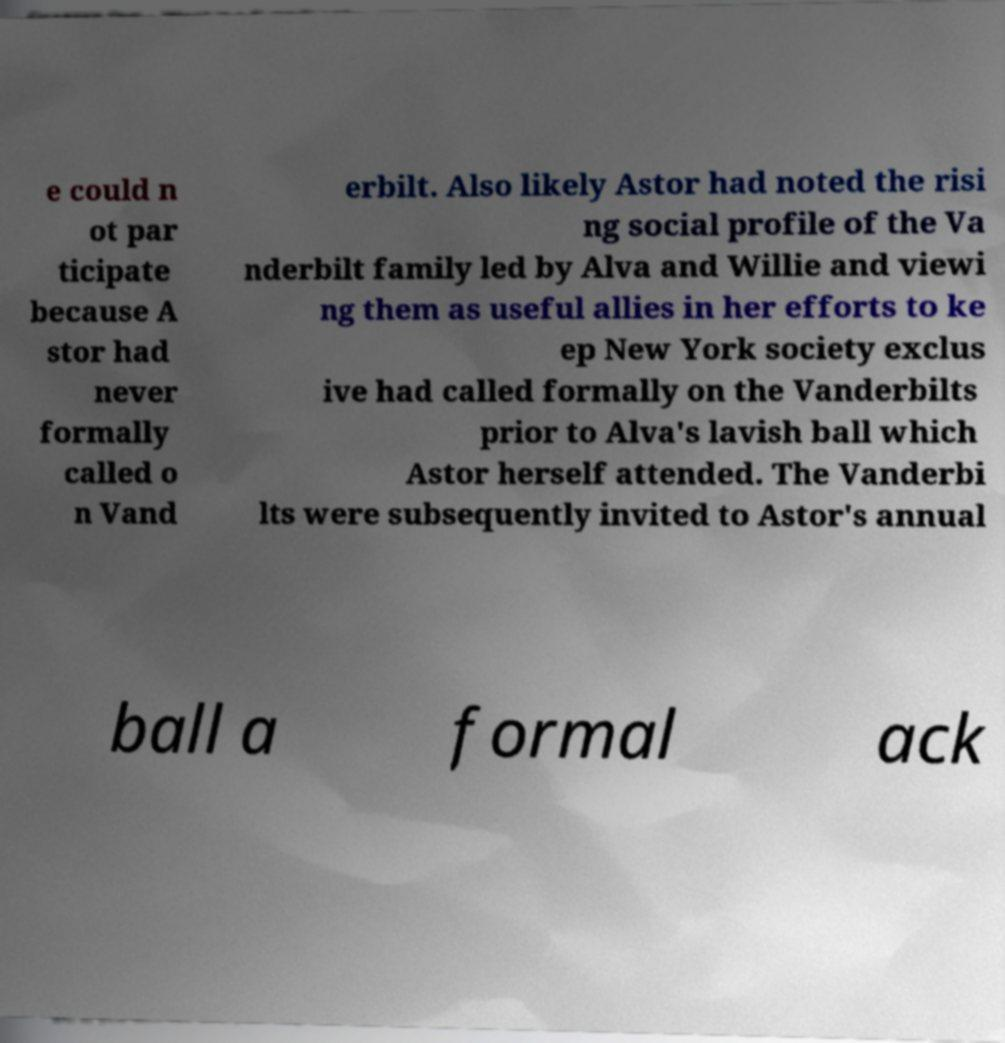Can you accurately transcribe the text from the provided image for me? e could n ot par ticipate because A stor had never formally called o n Vand erbilt. Also likely Astor had noted the risi ng social profile of the Va nderbilt family led by Alva and Willie and viewi ng them as useful allies in her efforts to ke ep New York society exclus ive had called formally on the Vanderbilts prior to Alva's lavish ball which Astor herself attended. The Vanderbi lts were subsequently invited to Astor's annual ball a formal ack 